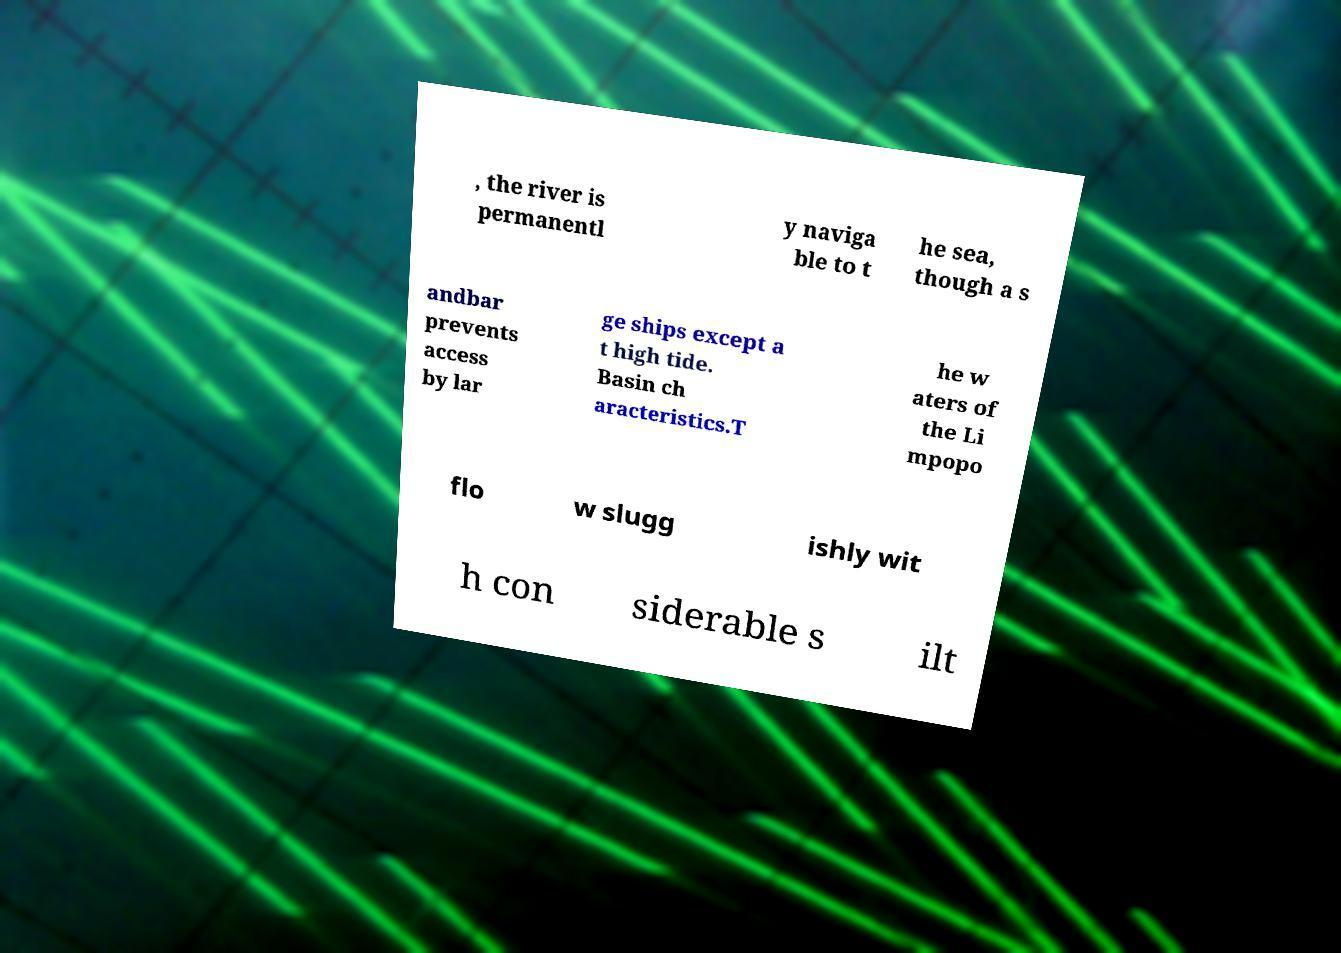Could you extract and type out the text from this image? , the river is permanentl y naviga ble to t he sea, though a s andbar prevents access by lar ge ships except a t high tide. Basin ch aracteristics.T he w aters of the Li mpopo flo w slugg ishly wit h con siderable s ilt 